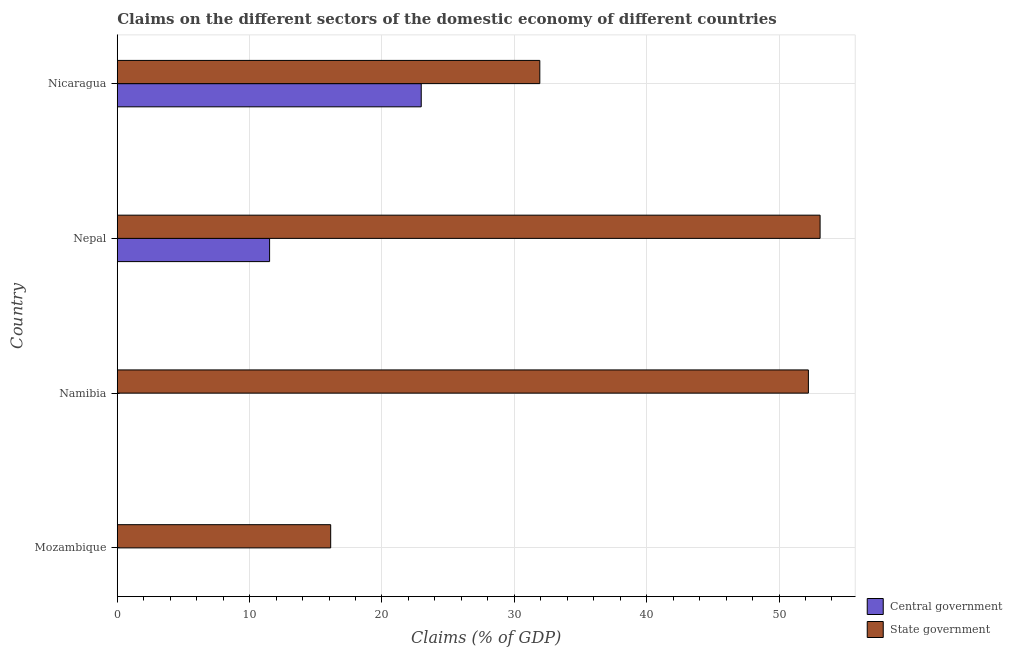How many different coloured bars are there?
Ensure brevity in your answer.  2. Are the number of bars per tick equal to the number of legend labels?
Make the answer very short. No. Are the number of bars on each tick of the Y-axis equal?
Your answer should be very brief. No. How many bars are there on the 2nd tick from the bottom?
Offer a terse response. 1. What is the label of the 4th group of bars from the top?
Ensure brevity in your answer.  Mozambique. What is the claims on central government in Mozambique?
Make the answer very short. 0. Across all countries, what is the maximum claims on central government?
Your answer should be compact. 22.97. In which country was the claims on central government maximum?
Provide a succinct answer. Nicaragua. What is the total claims on central government in the graph?
Offer a terse response. 34.48. What is the difference between the claims on state government in Mozambique and that in Namibia?
Your answer should be very brief. -36.09. What is the difference between the claims on central government in Namibia and the claims on state government in Nicaragua?
Make the answer very short. -31.93. What is the average claims on central government per country?
Your answer should be compact. 8.62. What is the difference between the claims on state government and claims on central government in Nicaragua?
Your answer should be very brief. 8.96. In how many countries, is the claims on state government greater than 12 %?
Make the answer very short. 4. What is the ratio of the claims on state government in Mozambique to that in Nicaragua?
Your answer should be compact. 0.51. What is the difference between the highest and the second highest claims on state government?
Make the answer very short. 0.88. What is the difference between the highest and the lowest claims on state government?
Make the answer very short. 36.98. How many bars are there?
Your answer should be very brief. 6. Are all the bars in the graph horizontal?
Your response must be concise. Yes. What is the difference between two consecutive major ticks on the X-axis?
Provide a succinct answer. 10. Where does the legend appear in the graph?
Provide a short and direct response. Bottom right. How many legend labels are there?
Keep it short and to the point. 2. What is the title of the graph?
Provide a short and direct response. Claims on the different sectors of the domestic economy of different countries. Does "Netherlands" appear as one of the legend labels in the graph?
Make the answer very short. No. What is the label or title of the X-axis?
Your answer should be compact. Claims (% of GDP). What is the Claims (% of GDP) in State government in Mozambique?
Give a very brief answer. 16.13. What is the Claims (% of GDP) in Central government in Namibia?
Provide a short and direct response. 0. What is the Claims (% of GDP) in State government in Namibia?
Your answer should be compact. 52.22. What is the Claims (% of GDP) of Central government in Nepal?
Give a very brief answer. 11.51. What is the Claims (% of GDP) in State government in Nepal?
Your answer should be very brief. 53.1. What is the Claims (% of GDP) of Central government in Nicaragua?
Your answer should be compact. 22.97. What is the Claims (% of GDP) in State government in Nicaragua?
Give a very brief answer. 31.93. Across all countries, what is the maximum Claims (% of GDP) in Central government?
Provide a succinct answer. 22.97. Across all countries, what is the maximum Claims (% of GDP) in State government?
Your answer should be compact. 53.1. Across all countries, what is the minimum Claims (% of GDP) in State government?
Give a very brief answer. 16.13. What is the total Claims (% of GDP) in Central government in the graph?
Offer a very short reply. 34.48. What is the total Claims (% of GDP) in State government in the graph?
Keep it short and to the point. 153.38. What is the difference between the Claims (% of GDP) of State government in Mozambique and that in Namibia?
Give a very brief answer. -36.09. What is the difference between the Claims (% of GDP) of State government in Mozambique and that in Nepal?
Provide a short and direct response. -36.98. What is the difference between the Claims (% of GDP) in State government in Mozambique and that in Nicaragua?
Your response must be concise. -15.8. What is the difference between the Claims (% of GDP) of State government in Namibia and that in Nepal?
Make the answer very short. -0.88. What is the difference between the Claims (% of GDP) of State government in Namibia and that in Nicaragua?
Make the answer very short. 20.29. What is the difference between the Claims (% of GDP) in Central government in Nepal and that in Nicaragua?
Your answer should be compact. -11.46. What is the difference between the Claims (% of GDP) of State government in Nepal and that in Nicaragua?
Offer a very short reply. 21.18. What is the difference between the Claims (% of GDP) in Central government in Nepal and the Claims (% of GDP) in State government in Nicaragua?
Keep it short and to the point. -20.42. What is the average Claims (% of GDP) in Central government per country?
Your answer should be compact. 8.62. What is the average Claims (% of GDP) of State government per country?
Offer a very short reply. 38.34. What is the difference between the Claims (% of GDP) of Central government and Claims (% of GDP) of State government in Nepal?
Ensure brevity in your answer.  -41.59. What is the difference between the Claims (% of GDP) of Central government and Claims (% of GDP) of State government in Nicaragua?
Offer a terse response. -8.96. What is the ratio of the Claims (% of GDP) in State government in Mozambique to that in Namibia?
Your response must be concise. 0.31. What is the ratio of the Claims (% of GDP) of State government in Mozambique to that in Nepal?
Offer a terse response. 0.3. What is the ratio of the Claims (% of GDP) in State government in Mozambique to that in Nicaragua?
Provide a succinct answer. 0.51. What is the ratio of the Claims (% of GDP) of State government in Namibia to that in Nepal?
Offer a terse response. 0.98. What is the ratio of the Claims (% of GDP) in State government in Namibia to that in Nicaragua?
Keep it short and to the point. 1.64. What is the ratio of the Claims (% of GDP) of Central government in Nepal to that in Nicaragua?
Give a very brief answer. 0.5. What is the ratio of the Claims (% of GDP) of State government in Nepal to that in Nicaragua?
Keep it short and to the point. 1.66. What is the difference between the highest and the second highest Claims (% of GDP) in State government?
Give a very brief answer. 0.88. What is the difference between the highest and the lowest Claims (% of GDP) in Central government?
Offer a very short reply. 22.97. What is the difference between the highest and the lowest Claims (% of GDP) of State government?
Offer a terse response. 36.98. 